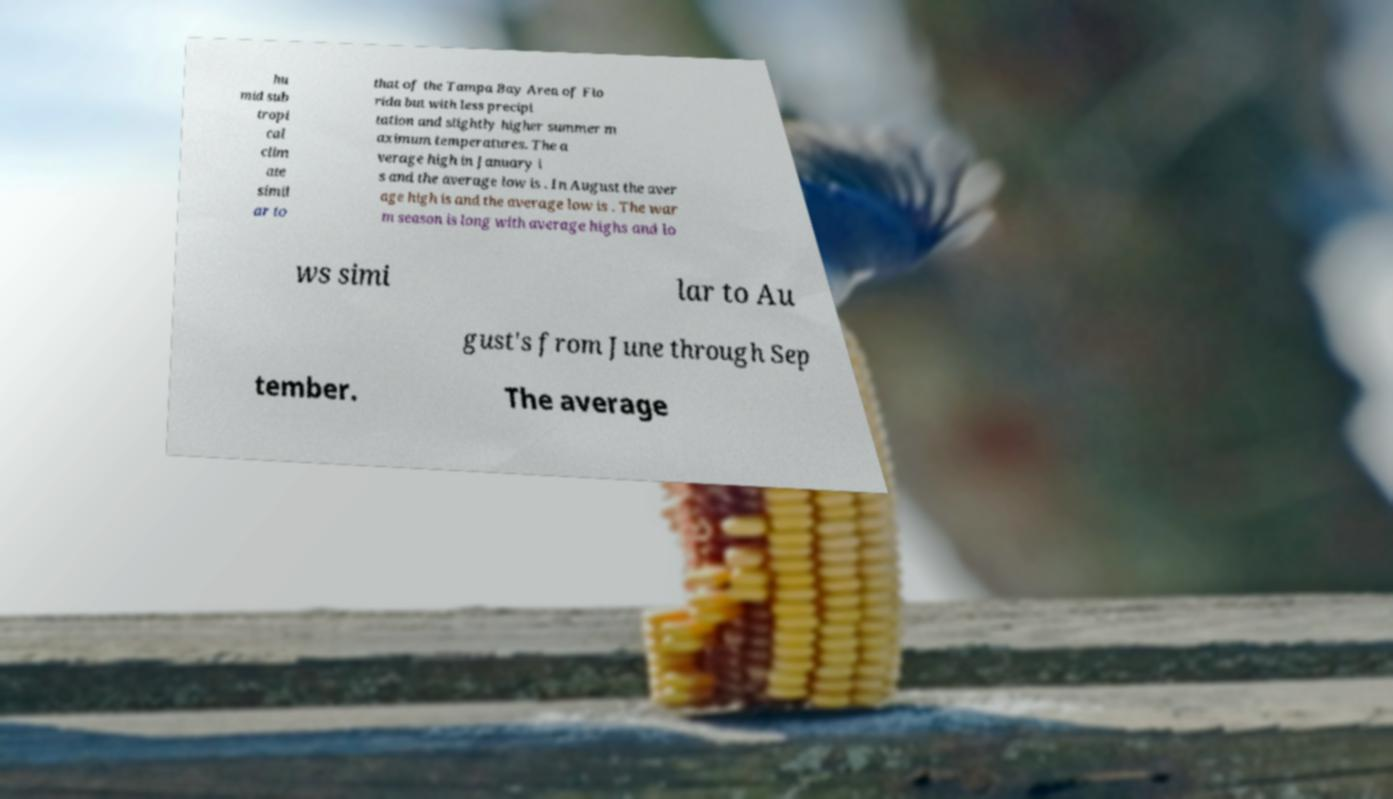Could you assist in decoding the text presented in this image and type it out clearly? hu mid sub tropi cal clim ate simil ar to that of the Tampa Bay Area of Flo rida but with less precipi tation and slightly higher summer m aximum temperatures. The a verage high in January i s and the average low is . In August the aver age high is and the average low is . The war m season is long with average highs and lo ws simi lar to Au gust's from June through Sep tember. The average 